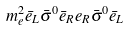Convert formula to latex. <formula><loc_0><loc_0><loc_500><loc_500>m _ { e } ^ { 2 } \bar { e } _ { L } \bar { \sigma } ^ { 0 } \bar { e } _ { R } e _ { R } \bar { \sigma } ^ { 0 } \bar { e } _ { L }</formula> 